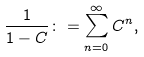Convert formula to latex. <formula><loc_0><loc_0><loc_500><loc_500>\frac { 1 } { 1 - C } \colon = \sum _ { n = 0 } ^ { \infty } C ^ { n } ,</formula> 